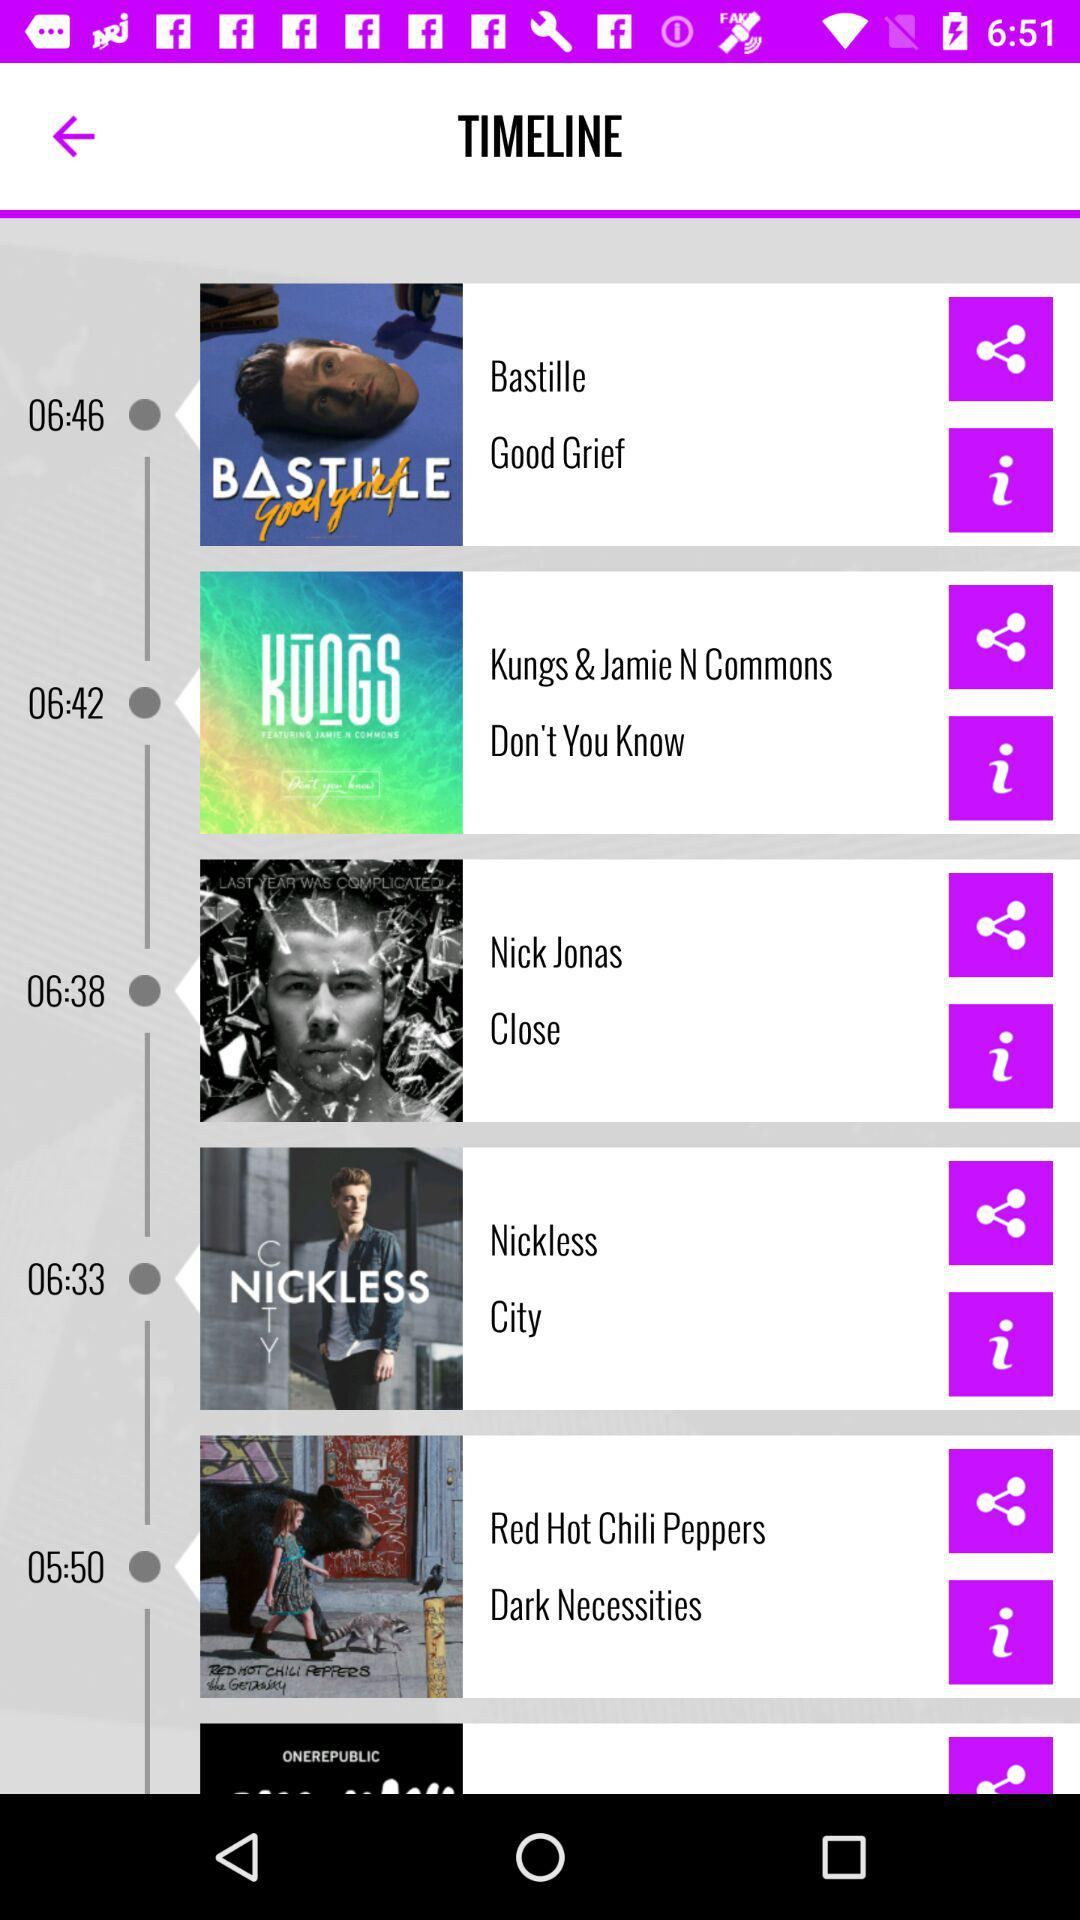Who is Nick Jonas?
When the provided information is insufficient, respond with <no answer>. <no answer> 